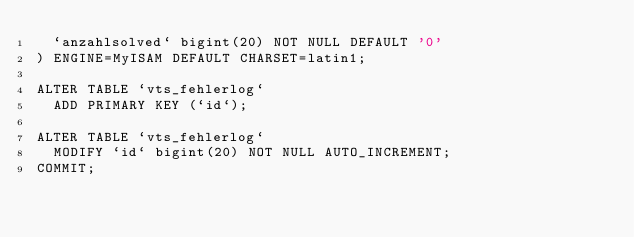<code> <loc_0><loc_0><loc_500><loc_500><_SQL_>  `anzahlsolved` bigint(20) NOT NULL DEFAULT '0'
) ENGINE=MyISAM DEFAULT CHARSET=latin1;

ALTER TABLE `vts_fehlerlog`
  ADD PRIMARY KEY (`id`);

ALTER TABLE `vts_fehlerlog`
  MODIFY `id` bigint(20) NOT NULL AUTO_INCREMENT;
COMMIT;

</code> 